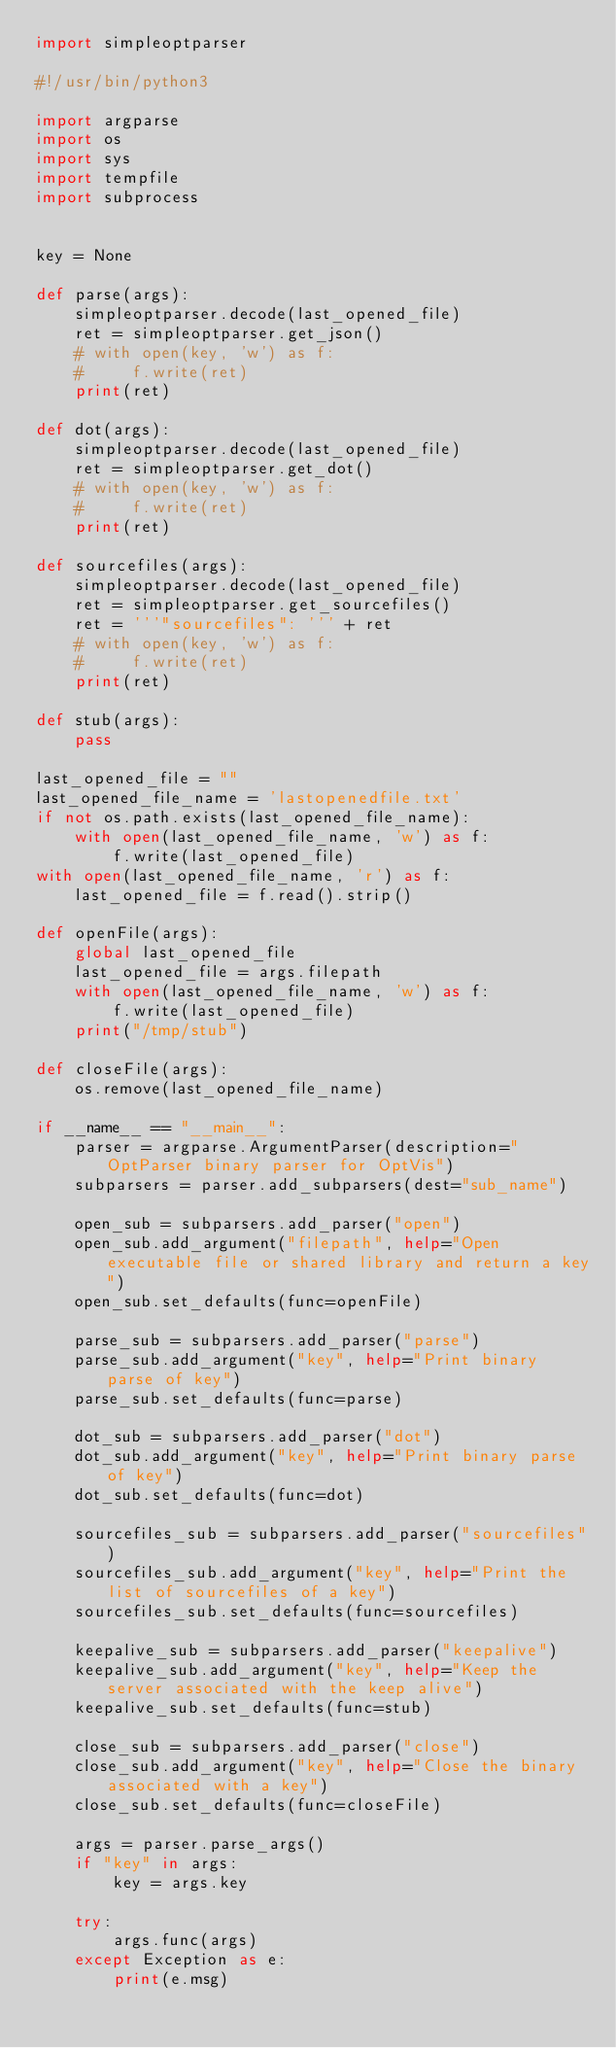<code> <loc_0><loc_0><loc_500><loc_500><_Python_>import simpleoptparser

#!/usr/bin/python3

import argparse
import os
import sys
import tempfile
import subprocess


key = None

def parse(args):
    simpleoptparser.decode(last_opened_file)
    ret = simpleoptparser.get_json()
    # with open(key, 'w') as f:
    #     f.write(ret)
    print(ret)

def dot(args):
    simpleoptparser.decode(last_opened_file)
    ret = simpleoptparser.get_dot()
    # with open(key, 'w') as f:
    #     f.write(ret)
    print(ret)

def sourcefiles(args):
    simpleoptparser.decode(last_opened_file)
    ret = simpleoptparser.get_sourcefiles()
    ret = '''"sourcefiles": ''' + ret
    # with open(key, 'w') as f:
    #     f.write(ret)
    print(ret)

def stub(args):
    pass

last_opened_file = ""
last_opened_file_name = 'lastopenedfile.txt'
if not os.path.exists(last_opened_file_name):
    with open(last_opened_file_name, 'w') as f:
        f.write(last_opened_file)
with open(last_opened_file_name, 'r') as f:
    last_opened_file = f.read().strip()

def openFile(args):
    global last_opened_file
    last_opened_file = args.filepath
    with open(last_opened_file_name, 'w') as f:
        f.write(last_opened_file)
    print("/tmp/stub")

def closeFile(args):
    os.remove(last_opened_file_name)

if __name__ == "__main__":
    parser = argparse.ArgumentParser(description="OptParser binary parser for OptVis")
    subparsers = parser.add_subparsers(dest="sub_name")

    open_sub = subparsers.add_parser("open")
    open_sub.add_argument("filepath", help="Open executable file or shared library and return a key")
    open_sub.set_defaults(func=openFile)

    parse_sub = subparsers.add_parser("parse")
    parse_sub.add_argument("key", help="Print binary parse of key")
    parse_sub.set_defaults(func=parse)

    dot_sub = subparsers.add_parser("dot")
    dot_sub.add_argument("key", help="Print binary parse of key")
    dot_sub.set_defaults(func=dot)

    sourcefiles_sub = subparsers.add_parser("sourcefiles")
    sourcefiles_sub.add_argument("key", help="Print the list of sourcefiles of a key")
    sourcefiles_sub.set_defaults(func=sourcefiles)

    keepalive_sub = subparsers.add_parser("keepalive")
    keepalive_sub.add_argument("key", help="Keep the server associated with the keep alive")
    keepalive_sub.set_defaults(func=stub)

    close_sub = subparsers.add_parser("close")
    close_sub.add_argument("key", help="Close the binary associated with a key")
    close_sub.set_defaults(func=closeFile)

    args = parser.parse_args()
    if "key" in args:
        key = args.key

    try:
        args.func(args)
    except Exception as e:
        print(e.msg)
</code> 